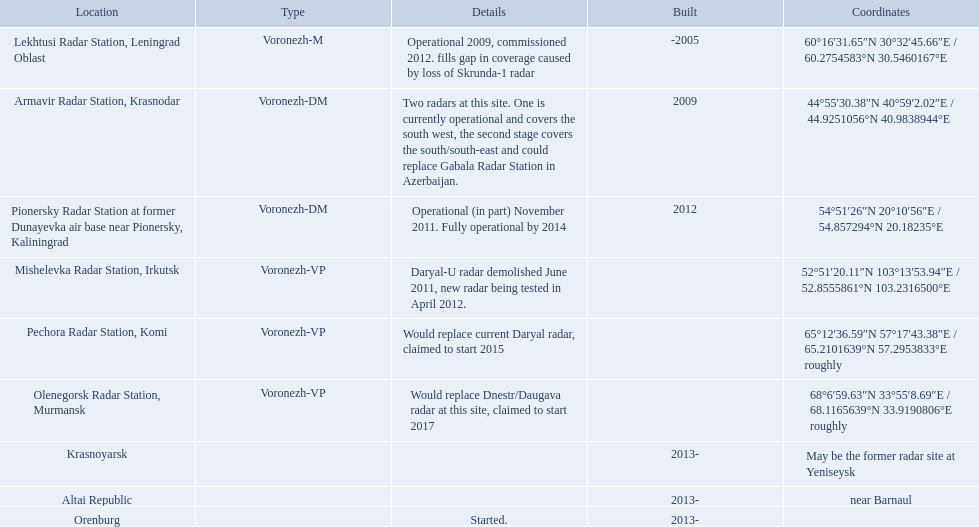Voronezh radar has locations where? Lekhtusi Radar Station, Leningrad Oblast, Armavir Radar Station, Krasnodar, Pionersky Radar Station at former Dunayevka air base near Pionersky, Kaliningrad, Mishelevka Radar Station, Irkutsk, Pechora Radar Station, Komi, Olenegorsk Radar Station, Murmansk, Krasnoyarsk, Altai Republic, Orenburg. Which of these locations have know coordinates? Lekhtusi Radar Station, Leningrad Oblast, Armavir Radar Station, Krasnodar, Pionersky Radar Station at former Dunayevka air base near Pionersky, Kaliningrad, Mishelevka Radar Station, Irkutsk, Pechora Radar Station, Komi, Olenegorsk Radar Station, Murmansk. Which of these locations has coordinates of 60deg16'31.65''n 30deg32'45.66''e / 60.2754583degn 30.5460167dege? Lekhtusi Radar Station, Leningrad Oblast. 